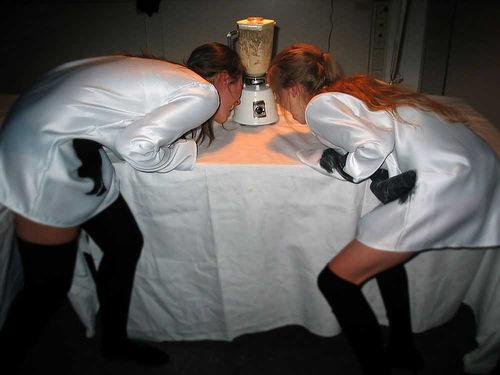What are the girls looking at?
Quick response, please. Blender. How many girls are present?
Quick response, please. 2. Does the blonde have her hair in a ponytail?
Write a very short answer. Yes. 